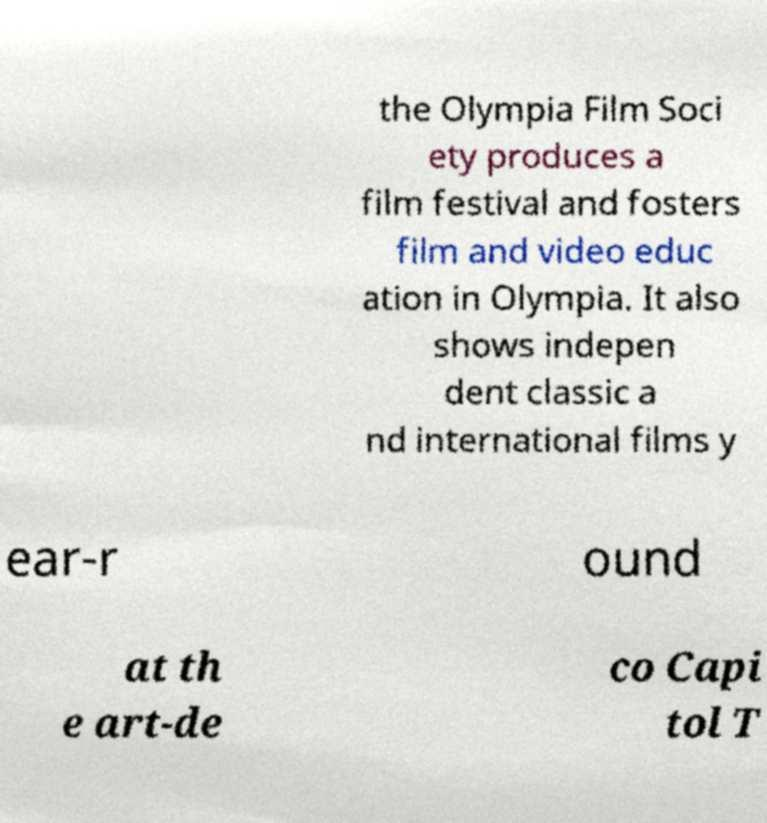There's text embedded in this image that I need extracted. Can you transcribe it verbatim? the Olympia Film Soci ety produces a film festival and fosters film and video educ ation in Olympia. It also shows indepen dent classic a nd international films y ear-r ound at th e art-de co Capi tol T 